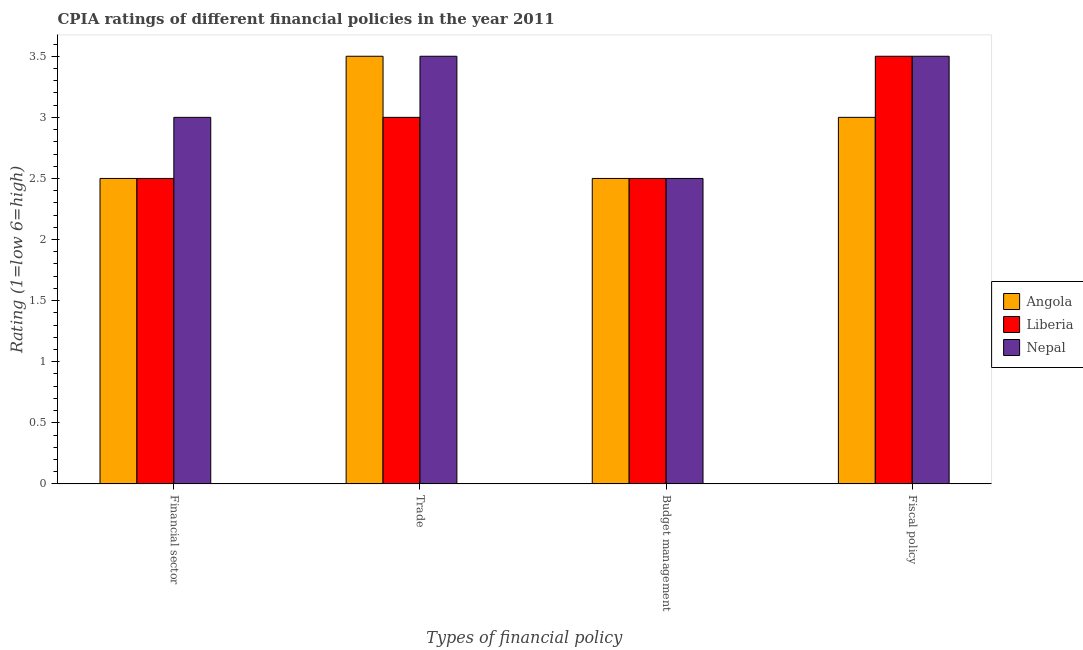How many groups of bars are there?
Ensure brevity in your answer.  4. What is the label of the 1st group of bars from the left?
Offer a terse response. Financial sector. What is the cpia rating of fiscal policy in Liberia?
Keep it short and to the point. 3.5. Across all countries, what is the maximum cpia rating of fiscal policy?
Your answer should be compact. 3.5. In which country was the cpia rating of budget management maximum?
Keep it short and to the point. Angola. In which country was the cpia rating of trade minimum?
Offer a very short reply. Liberia. What is the total cpia rating of financial sector in the graph?
Offer a very short reply. 8. What is the difference between the cpia rating of financial sector in Liberia and that in Nepal?
Ensure brevity in your answer.  -0.5. What is the average cpia rating of financial sector per country?
Ensure brevity in your answer.  2.67. In how many countries, is the cpia rating of budget management greater than 0.9 ?
Ensure brevity in your answer.  3. What is the ratio of the cpia rating of financial sector in Nepal to that in Angola?
Keep it short and to the point. 1.2. What is the difference between the highest and the second highest cpia rating of fiscal policy?
Keep it short and to the point. 0. Is the sum of the cpia rating of fiscal policy in Liberia and Angola greater than the maximum cpia rating of financial sector across all countries?
Your answer should be compact. Yes. What does the 1st bar from the left in Financial sector represents?
Keep it short and to the point. Angola. What does the 3rd bar from the right in Fiscal policy represents?
Offer a very short reply. Angola. Is it the case that in every country, the sum of the cpia rating of financial sector and cpia rating of trade is greater than the cpia rating of budget management?
Offer a very short reply. Yes. How many bars are there?
Make the answer very short. 12. Are all the bars in the graph horizontal?
Offer a terse response. No. How many countries are there in the graph?
Offer a terse response. 3. Does the graph contain any zero values?
Your answer should be very brief. No. How are the legend labels stacked?
Make the answer very short. Vertical. What is the title of the graph?
Your answer should be very brief. CPIA ratings of different financial policies in the year 2011. Does "Bahrain" appear as one of the legend labels in the graph?
Your answer should be very brief. No. What is the label or title of the X-axis?
Offer a terse response. Types of financial policy. What is the Rating (1=low 6=high) in Liberia in Financial sector?
Give a very brief answer. 2.5. What is the Rating (1=low 6=high) in Nepal in Financial sector?
Your answer should be very brief. 3. What is the Rating (1=low 6=high) of Liberia in Trade?
Your response must be concise. 3. What is the Rating (1=low 6=high) in Nepal in Trade?
Keep it short and to the point. 3.5. What is the Rating (1=low 6=high) in Angola in Budget management?
Provide a short and direct response. 2.5. What is the Rating (1=low 6=high) in Nepal in Budget management?
Keep it short and to the point. 2.5. What is the Rating (1=low 6=high) in Angola in Fiscal policy?
Provide a succinct answer. 3. What is the Rating (1=low 6=high) of Liberia in Fiscal policy?
Make the answer very short. 3.5. Across all Types of financial policy, what is the maximum Rating (1=low 6=high) of Nepal?
Your answer should be very brief. 3.5. Across all Types of financial policy, what is the minimum Rating (1=low 6=high) of Nepal?
Offer a very short reply. 2.5. What is the total Rating (1=low 6=high) in Nepal in the graph?
Make the answer very short. 12.5. What is the difference between the Rating (1=low 6=high) in Angola in Financial sector and that in Trade?
Provide a short and direct response. -1. What is the difference between the Rating (1=low 6=high) in Nepal in Financial sector and that in Budget management?
Provide a short and direct response. 0.5. What is the difference between the Rating (1=low 6=high) in Liberia in Financial sector and that in Fiscal policy?
Your answer should be very brief. -1. What is the difference between the Rating (1=low 6=high) of Nepal in Financial sector and that in Fiscal policy?
Provide a short and direct response. -0.5. What is the difference between the Rating (1=low 6=high) in Nepal in Trade and that in Budget management?
Provide a short and direct response. 1. What is the difference between the Rating (1=low 6=high) of Nepal in Trade and that in Fiscal policy?
Keep it short and to the point. 0. What is the difference between the Rating (1=low 6=high) of Angola in Financial sector and the Rating (1=low 6=high) of Liberia in Budget management?
Provide a short and direct response. 0. What is the difference between the Rating (1=low 6=high) of Liberia in Financial sector and the Rating (1=low 6=high) of Nepal in Budget management?
Offer a very short reply. 0. What is the difference between the Rating (1=low 6=high) of Angola in Trade and the Rating (1=low 6=high) of Liberia in Budget management?
Keep it short and to the point. 1. What is the difference between the Rating (1=low 6=high) in Angola in Trade and the Rating (1=low 6=high) in Nepal in Budget management?
Provide a short and direct response. 1. What is the difference between the Rating (1=low 6=high) of Liberia in Trade and the Rating (1=low 6=high) of Nepal in Budget management?
Make the answer very short. 0.5. What is the difference between the Rating (1=low 6=high) of Liberia in Trade and the Rating (1=low 6=high) of Nepal in Fiscal policy?
Provide a short and direct response. -0.5. What is the difference between the Rating (1=low 6=high) in Angola in Budget management and the Rating (1=low 6=high) in Liberia in Fiscal policy?
Keep it short and to the point. -1. What is the difference between the Rating (1=low 6=high) of Angola in Budget management and the Rating (1=low 6=high) of Nepal in Fiscal policy?
Your answer should be compact. -1. What is the average Rating (1=low 6=high) in Angola per Types of financial policy?
Your response must be concise. 2.88. What is the average Rating (1=low 6=high) in Liberia per Types of financial policy?
Make the answer very short. 2.88. What is the average Rating (1=low 6=high) of Nepal per Types of financial policy?
Your answer should be very brief. 3.12. What is the difference between the Rating (1=low 6=high) in Angola and Rating (1=low 6=high) in Liberia in Financial sector?
Offer a very short reply. 0. What is the difference between the Rating (1=low 6=high) in Angola and Rating (1=low 6=high) in Nepal in Trade?
Your answer should be very brief. 0. What is the difference between the Rating (1=low 6=high) of Angola and Rating (1=low 6=high) of Liberia in Budget management?
Make the answer very short. 0. What is the difference between the Rating (1=low 6=high) of Liberia and Rating (1=low 6=high) of Nepal in Fiscal policy?
Ensure brevity in your answer.  0. What is the ratio of the Rating (1=low 6=high) in Liberia in Financial sector to that in Trade?
Make the answer very short. 0.83. What is the ratio of the Rating (1=low 6=high) of Nepal in Financial sector to that in Trade?
Ensure brevity in your answer.  0.86. What is the ratio of the Rating (1=low 6=high) of Nepal in Financial sector to that in Budget management?
Offer a terse response. 1.2. What is the ratio of the Rating (1=low 6=high) in Nepal in Financial sector to that in Fiscal policy?
Your answer should be very brief. 0.86. What is the ratio of the Rating (1=low 6=high) in Liberia in Trade to that in Budget management?
Your answer should be compact. 1.2. What is the ratio of the Rating (1=low 6=high) in Angola in Trade to that in Fiscal policy?
Make the answer very short. 1.17. What is the ratio of the Rating (1=low 6=high) of Liberia in Trade to that in Fiscal policy?
Provide a short and direct response. 0.86. What is the ratio of the Rating (1=low 6=high) of Liberia in Budget management to that in Fiscal policy?
Your answer should be very brief. 0.71. What is the difference between the highest and the second highest Rating (1=low 6=high) in Liberia?
Keep it short and to the point. 0.5. What is the difference between the highest and the lowest Rating (1=low 6=high) in Nepal?
Give a very brief answer. 1. 